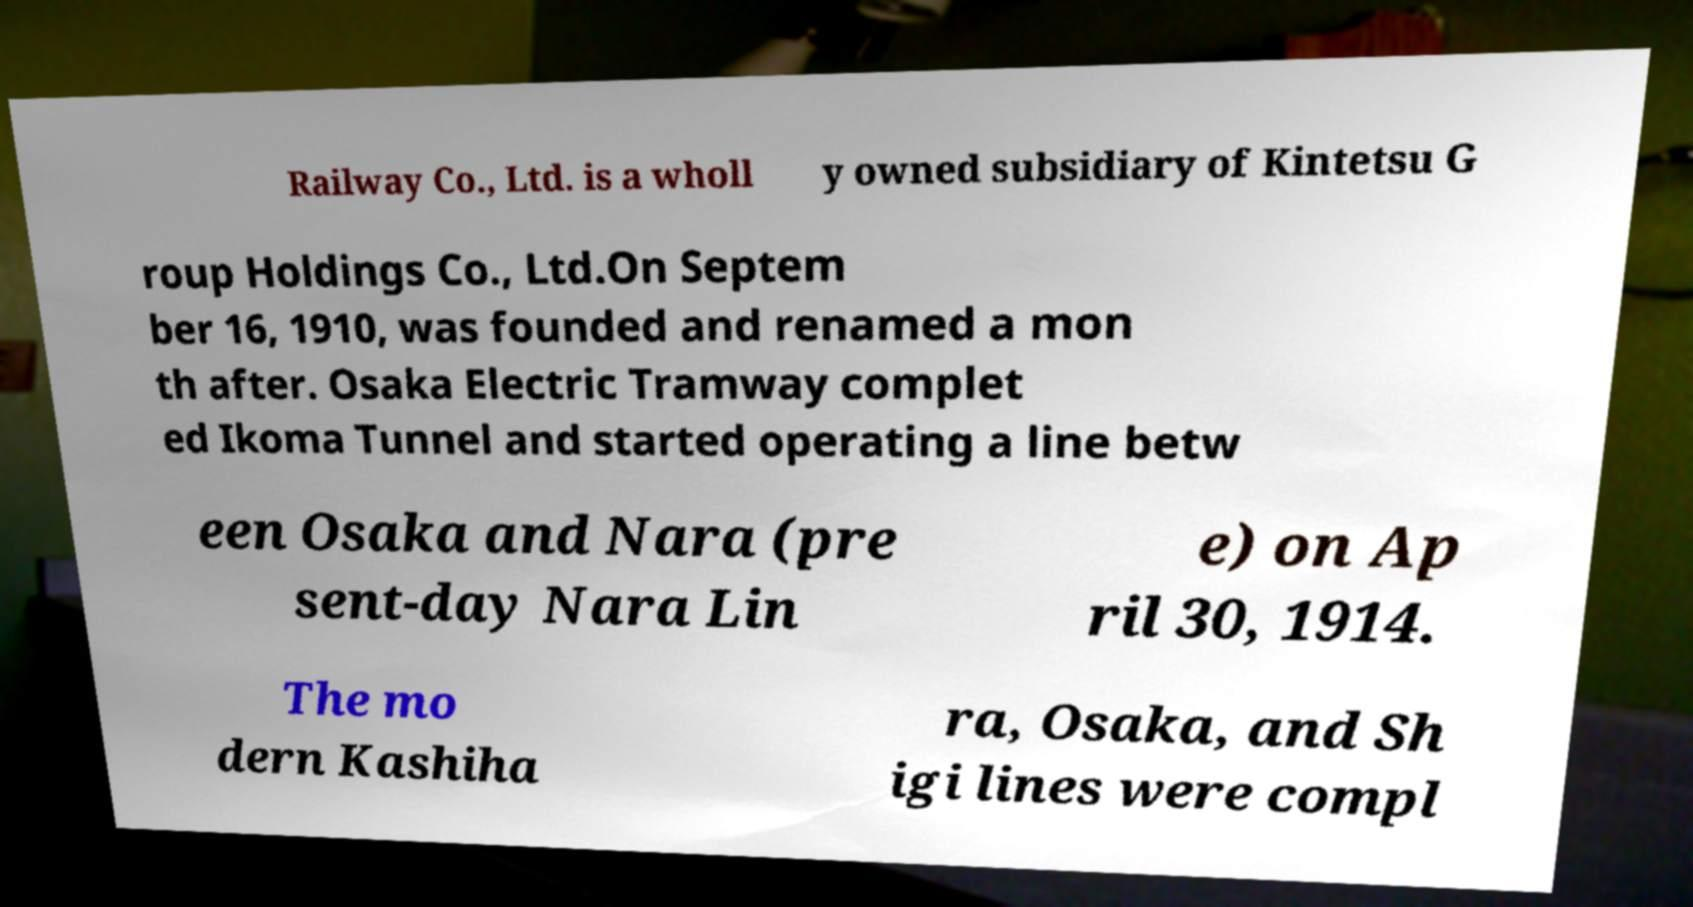For documentation purposes, I need the text within this image transcribed. Could you provide that? Railway Co., Ltd. is a wholl y owned subsidiary of Kintetsu G roup Holdings Co., Ltd.On Septem ber 16, 1910, was founded and renamed a mon th after. Osaka Electric Tramway complet ed Ikoma Tunnel and started operating a line betw een Osaka and Nara (pre sent-day Nara Lin e) on Ap ril 30, 1914. The mo dern Kashiha ra, Osaka, and Sh igi lines were compl 